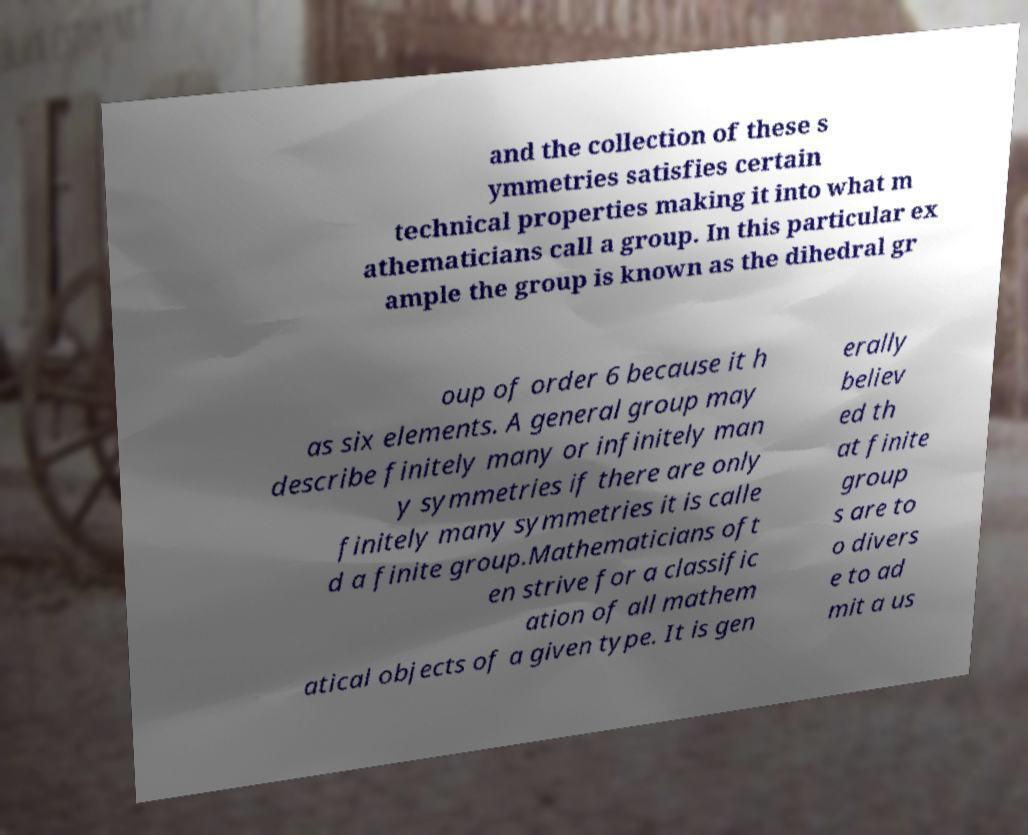Can you read and provide the text displayed in the image?This photo seems to have some interesting text. Can you extract and type it out for me? and the collection of these s ymmetries satisfies certain technical properties making it into what m athematicians call a group. In this particular ex ample the group is known as the dihedral gr oup of order 6 because it h as six elements. A general group may describe finitely many or infinitely man y symmetries if there are only finitely many symmetries it is calle d a finite group.Mathematicians oft en strive for a classific ation of all mathem atical objects of a given type. It is gen erally believ ed th at finite group s are to o divers e to ad mit a us 